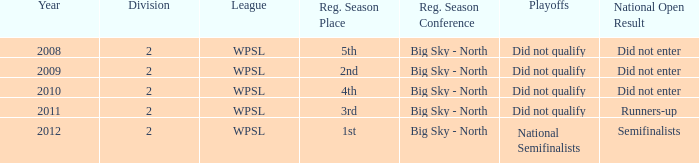What is the lowest division number? 2.0. 